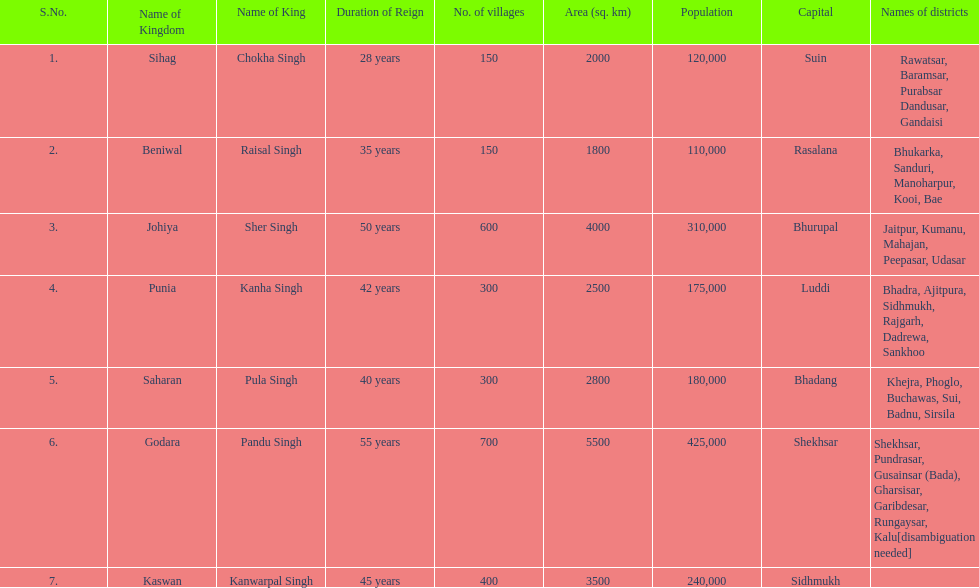He was the king of the sihag kingdom. Chokha Singh. 